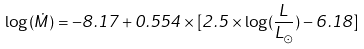<formula> <loc_0><loc_0><loc_500><loc_500>\log ( \dot { M } ) = - 8 . 1 7 + 0 . 5 5 4 \times [ 2 . 5 \times \log ( \frac { L } { L _ { \odot } } ) - 6 . 1 8 ]</formula> 